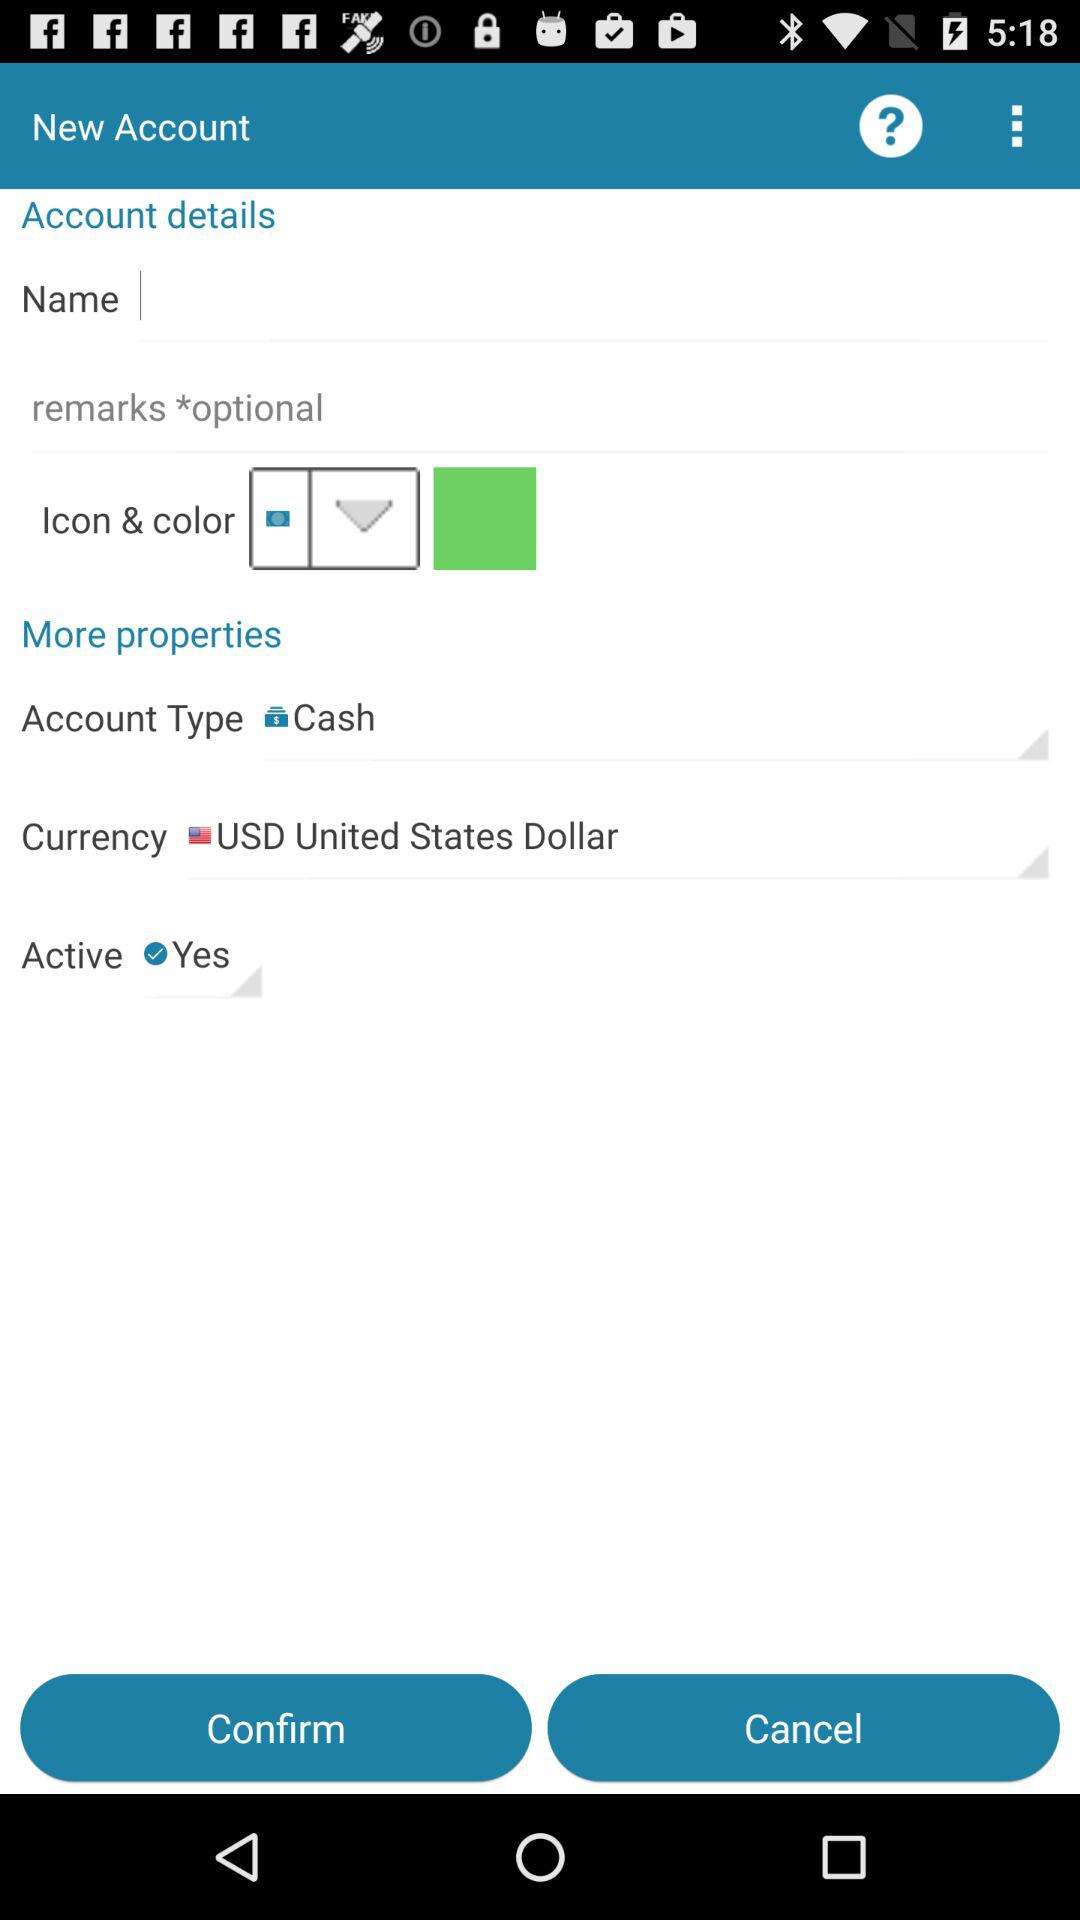What is the currency? The currency is the United States dollar. 